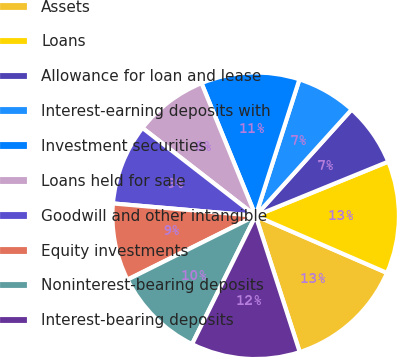Convert chart. <chart><loc_0><loc_0><loc_500><loc_500><pie_chart><fcel>Assets<fcel>Loans<fcel>Allowance for loan and lease<fcel>Interest-earning deposits with<fcel>Investment securities<fcel>Loans held for sale<fcel>Goodwill and other intangible<fcel>Equity investments<fcel>Noninterest-bearing deposits<fcel>Interest-bearing deposits<nl><fcel>13.49%<fcel>12.7%<fcel>7.14%<fcel>6.75%<fcel>11.11%<fcel>8.33%<fcel>9.13%<fcel>8.73%<fcel>10.32%<fcel>12.3%<nl></chart> 